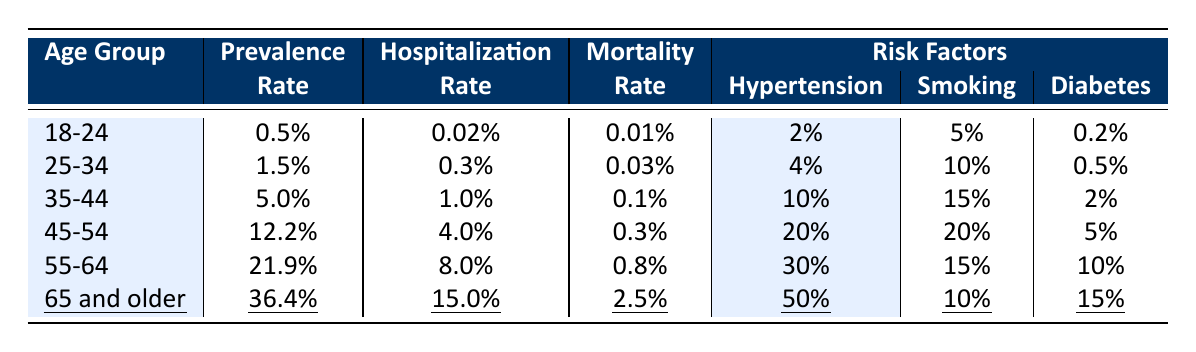What is the prevalence rate for the age group 45-54? The prevalence rate for the age group 45-54 is listed directly in the table as 12.2%.
Answer: 12.2% What is the hospitalization rate for individuals aged 35-44? The hospitalization rate for the age group 35-44 can be directly found in the table as 1.0%.
Answer: 1.0% Is the mortality rate for the 25-34 age group higher than that for the 18-24 age group? The mortality rate for the 25-34 age group is 0.03%, while the rate for the 18-24 age group is 0.01%. Since 0.03% is greater than 0.01%, the statement is true.
Answer: Yes What is the difference in the prevalence rates between the 55-64 age group and the 25-34 age group? The prevalence rate for the 55-64 age group is 21.9% and for the 25-34 age group is 1.5%. The difference is calculated as 21.9% - 1.5% = 20.4%.
Answer: 20.4% What percentage of individuals aged 65 and older have hypertension? The percentage of individuals aged 65 and older with hypertension is listed in the risk factors as 50%.
Answer: 50% Which age group has the highest hospitalization rate, and what is that rate? By examining the hospitalization rates in the table, the group aged 65 and older has the highest rate at 15.0%.
Answer: 15.0% What is the average prevalence rate for the age groups 35-44, 45-54, and 55-64? The prevalence rates for these groups are 5.0%, 12.2%, and 21.9%, respectively. The average is calculated as (5.0% + 12.2% + 21.9%) / 3 = 13.0%.
Answer: 13.0% Are there more risk factors for smoking in the age group 45-54 compared to 18-24? The smoking rate for the age group 45-54 is 20%, while for the 18-24 age group it is 5%. Since 20% is greater than 5%, the statement is true.
Answer: Yes What can be concluded about the trend in mortality rates as age increases? By reviewing the mortality rates, they increase from 0.01% in the 18-24 age group to 2.5% in the 65 and older age group, indicating a clear upward trend with age.
Answer: There is an upward trend What is the combined prevalence of diabetes in the age groups 55-64 and 65 and older? The prevalence of diabetes is 10% in the 55-64 age group and 15% in the 65 and older age group. The combined prevalence is 10% + 15% = 25%.
Answer: 25% 